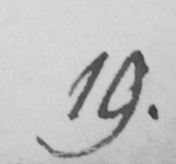Transcribe the text shown in this historical manuscript line. 19 . 